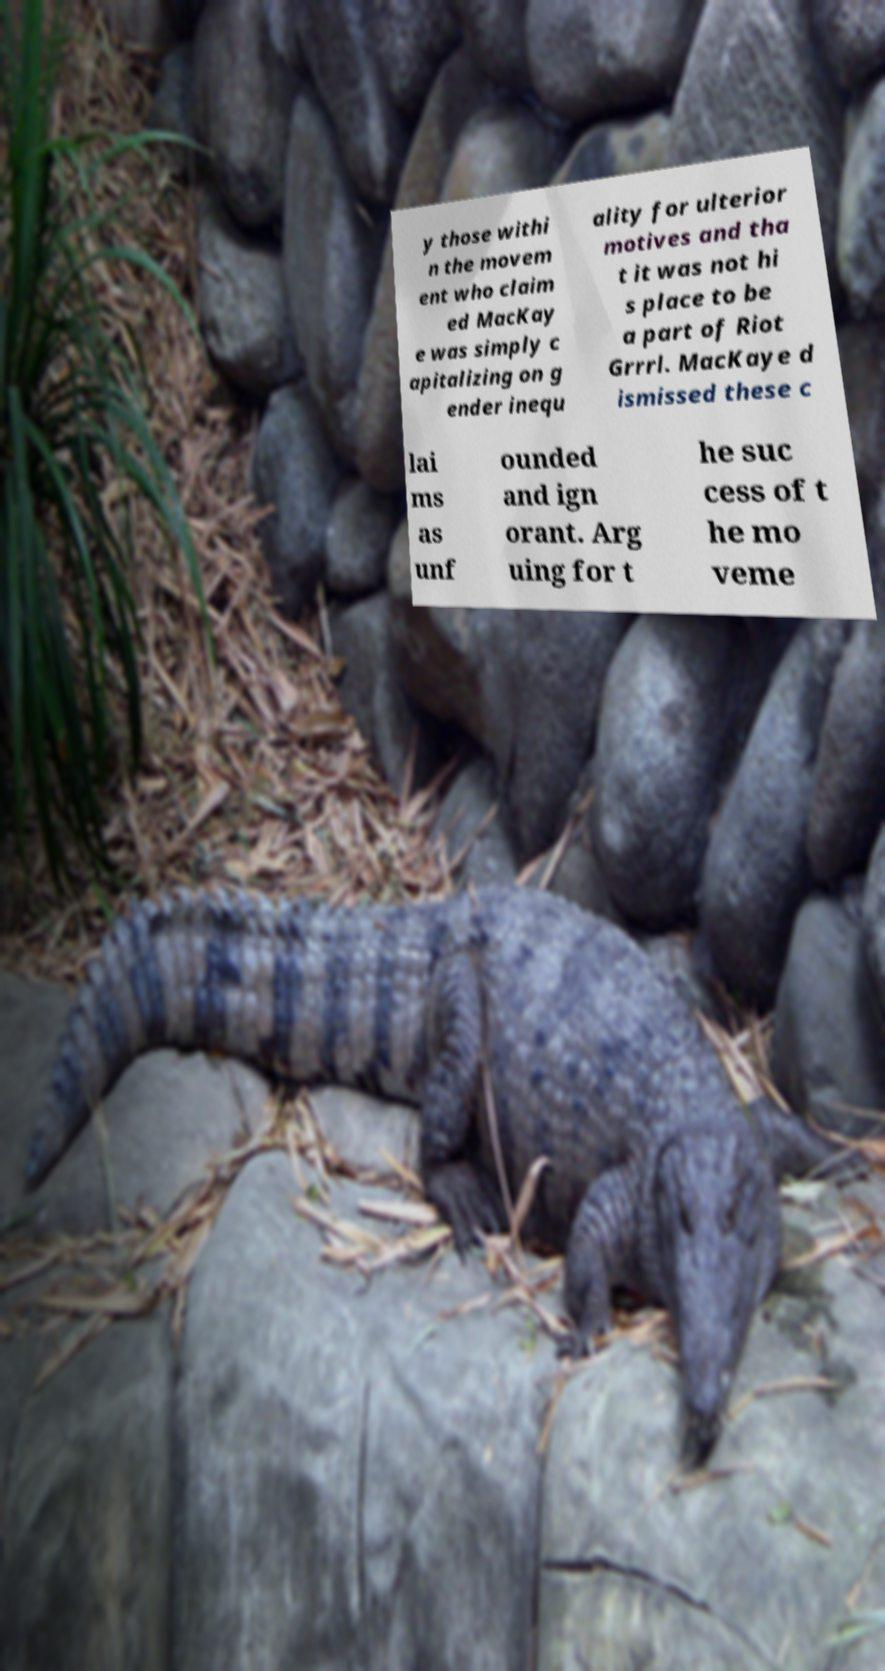Could you assist in decoding the text presented in this image and type it out clearly? y those withi n the movem ent who claim ed MacKay e was simply c apitalizing on g ender inequ ality for ulterior motives and tha t it was not hi s place to be a part of Riot Grrrl. MacKaye d ismissed these c lai ms as unf ounded and ign orant. Arg uing for t he suc cess of t he mo veme 